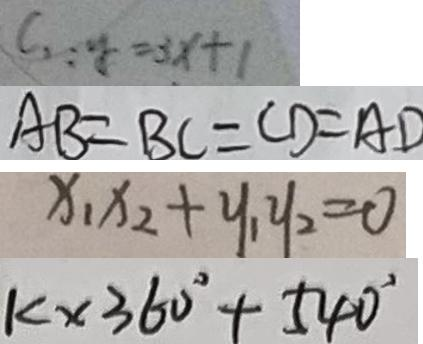<formula> <loc_0><loc_0><loc_500><loc_500>c _ { 2 } : y = 3 x + 1 
 A B = B C = C D = A D 
 x _ { 1 } x _ { 2 } + y _ { 1 } y _ { 2 } = 0 
 k \times 3 6 0 ^ { \circ } + 5 4 0 ^ { \circ }</formula> 